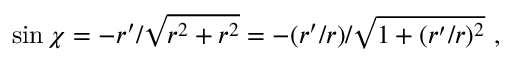<formula> <loc_0><loc_0><loc_500><loc_500>\sin \chi = - r ^ { \prime } / \sqrt { r ^ { 2 } + r ^ { 2 } } = - ( r ^ { \prime } / r ) / \sqrt { 1 + ( r ^ { \prime } / r ) ^ { 2 } } \ ,</formula> 